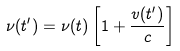Convert formula to latex. <formula><loc_0><loc_0><loc_500><loc_500>\nu ( t ^ { \prime } ) = \nu ( t ) \left [ 1 + \frac { v ( t ^ { \prime } ) } { c } \right ]</formula> 